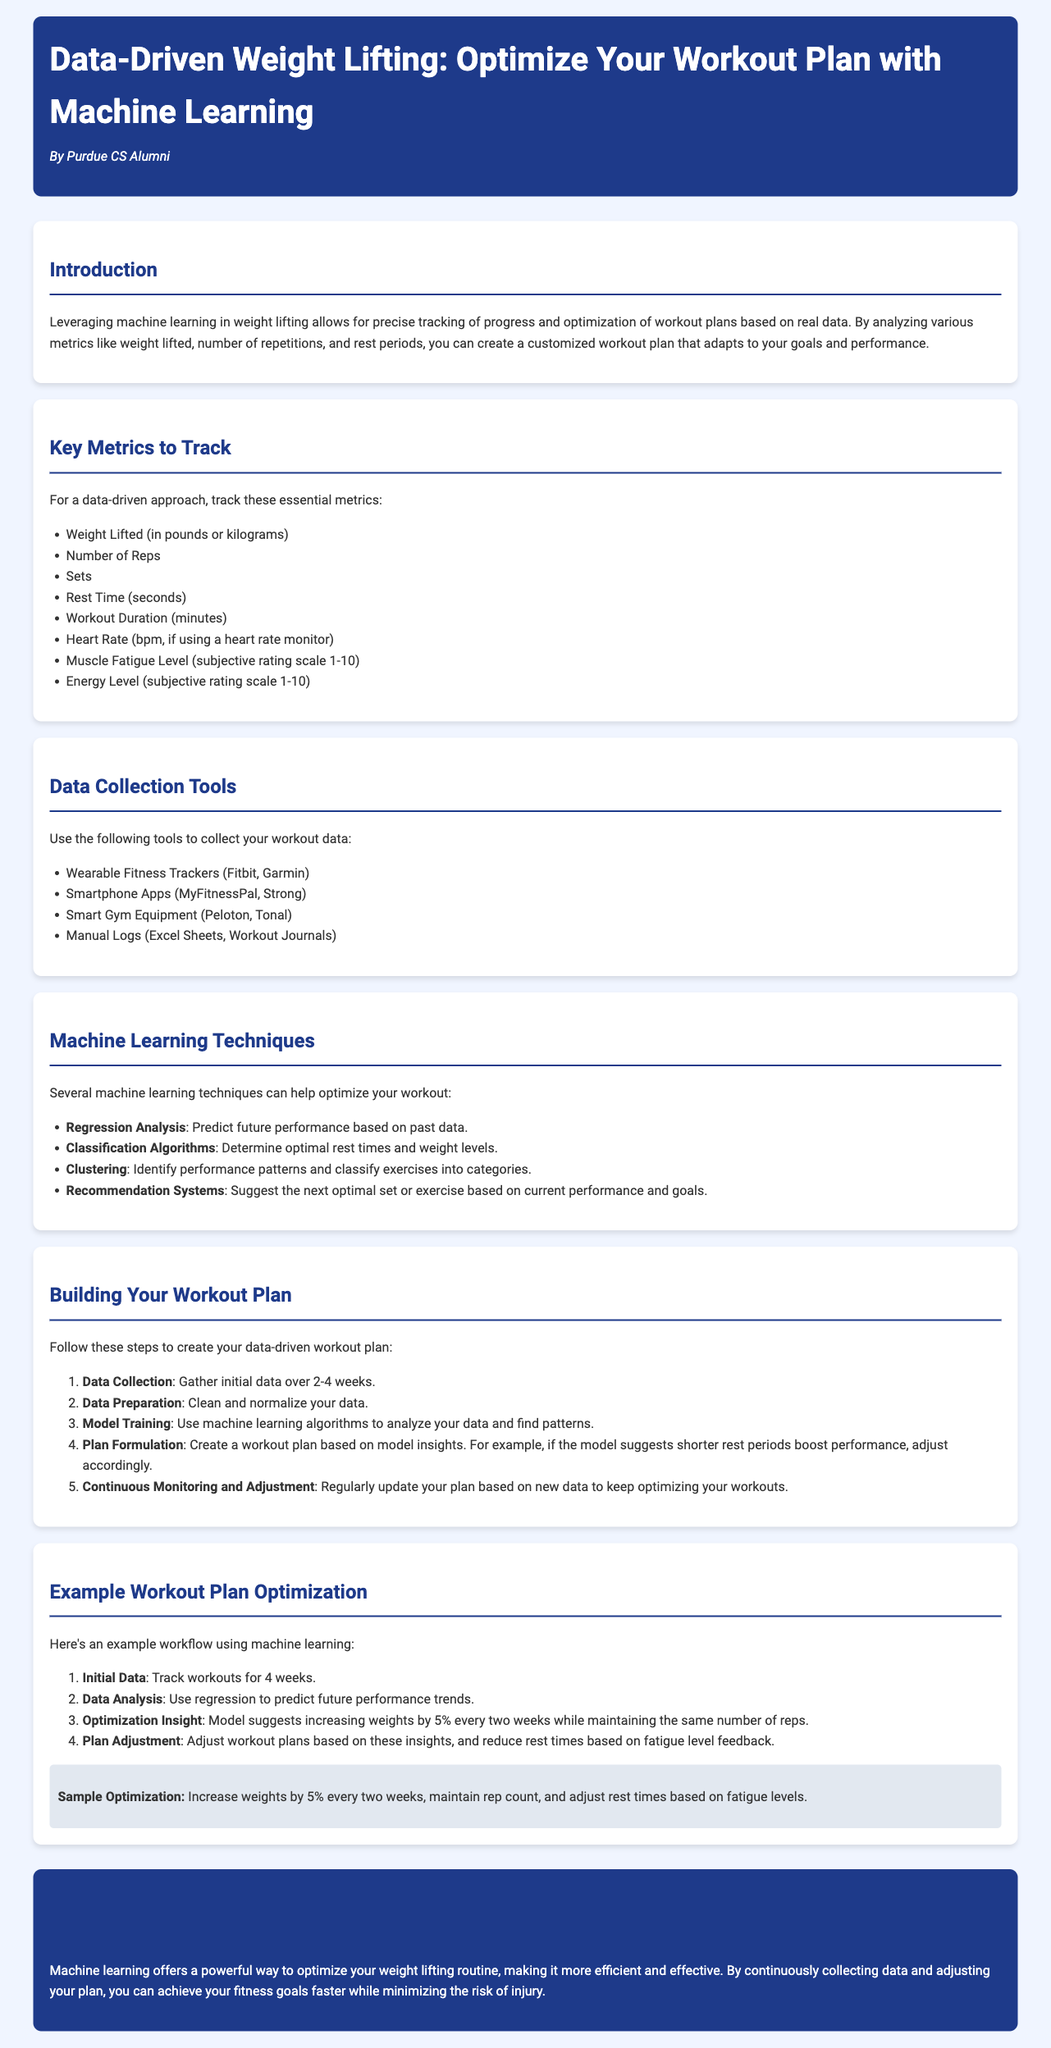What is the main topic of the document? The main topic focuses on using machine learning to optimize a weight lifting workout plan.
Answer: Data-Driven Weight Lifting How many key metrics are suggested to track? The document lists eight essential metrics to track for a data-driven approach to weight lifting.
Answer: Eight What tool is suggested for manual data logging? One of the tools listed for data collection is manual logging via spreadsheets or journals.
Answer: Excel Sheets What machine learning technique is mentioned for predicting performance? The technique used to predict future performance based on past data is called regression analysis.
Answer: Regression Analysis What is the recommended initial data collection period? The document suggests gathering initial data over a span of 2 to 4 weeks.
Answer: 2-4 weeks What should be done after model training according to the document? After model training, the next step is to create a workout plan based on the insights gained from the model.
Answer: Plan Formulation What is the example optimization strategy provided? The document advises increasing weights by 5% every two weeks while maintaining the same number of reps.
Answer: Increase weights by 5% every two weeks What percentage increase in weight is suggested by the optimization insight? The optimization insight suggests an increase of 5% in weights.
Answer: 5% What is the subjective scale used for muscle fatigue levels? The document indicates a subjective rating scale from 1 to 10 for assessing muscle fatigue levels.
Answer: 1-10 